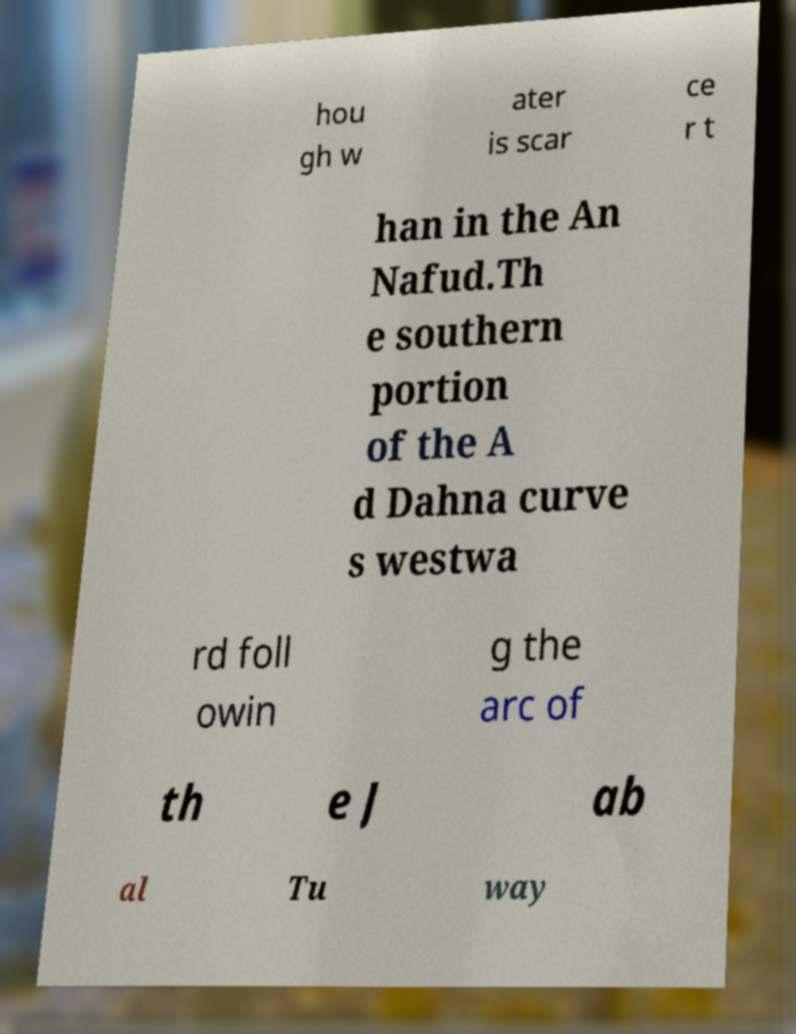Could you assist in decoding the text presented in this image and type it out clearly? hou gh w ater is scar ce r t han in the An Nafud.Th e southern portion of the A d Dahna curve s westwa rd foll owin g the arc of th e J ab al Tu way 